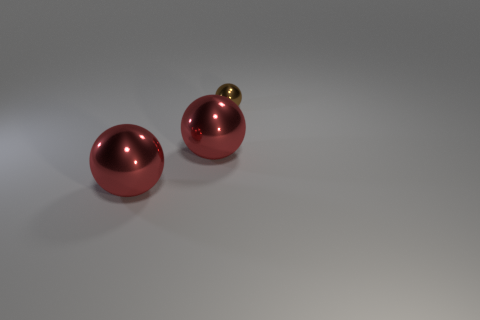What number of other shiny balls have the same size as the brown metallic ball?
Your answer should be compact. 0. How many green things are large metallic things or tiny objects?
Keep it short and to the point. 0. The small shiny ball has what color?
Your answer should be very brief. Brown. How many big red objects are the same shape as the small brown thing?
Make the answer very short. 2. Are there any other things that have the same size as the brown sphere?
Offer a very short reply. No. Is there a purple sphere that has the same material as the small brown thing?
Keep it short and to the point. No. Is there anything else that has the same color as the tiny metal sphere?
Provide a short and direct response. No. Is the number of tiny brown metallic things behind the brown shiny sphere less than the number of big red metallic objects?
Keep it short and to the point. Yes. What number of small balls are there?
Make the answer very short. 1. Is there anything else that has the same shape as the small brown object?
Make the answer very short. Yes. 